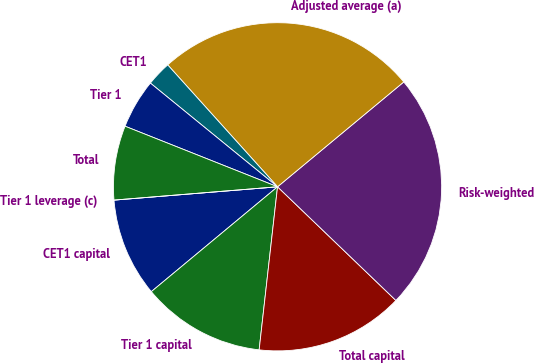Convert chart. <chart><loc_0><loc_0><loc_500><loc_500><pie_chart><fcel>CET1 capital<fcel>Tier 1 capital<fcel>Total capital<fcel>Risk-weighted<fcel>Adjusted average (a)<fcel>CET1<fcel>Tier 1<fcel>Total<fcel>Tier 1 leverage (c)<nl><fcel>9.74%<fcel>12.18%<fcel>14.61%<fcel>23.21%<fcel>25.64%<fcel>2.44%<fcel>4.87%<fcel>7.31%<fcel>0.0%<nl></chart> 